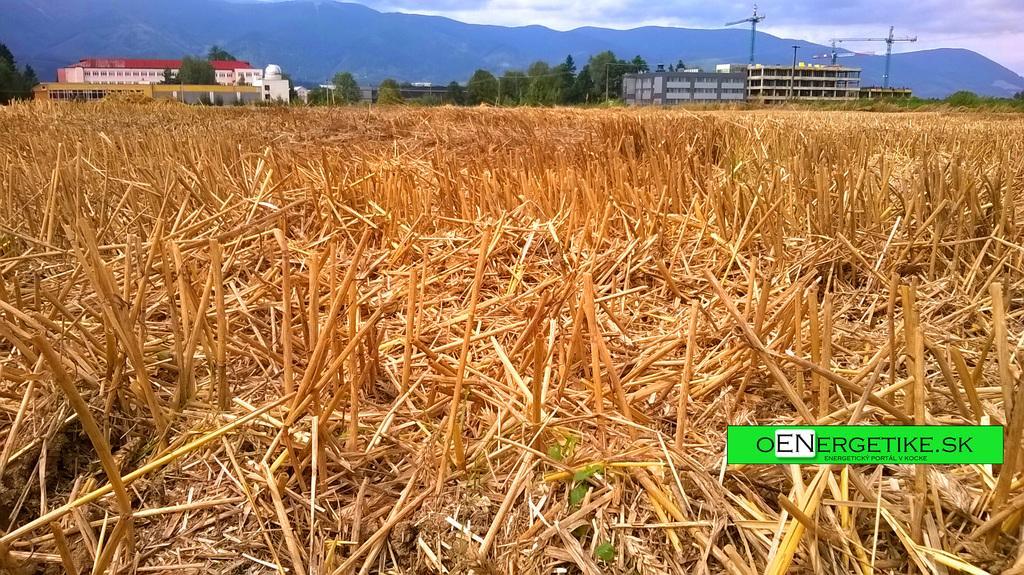Could you give a brief overview of what you see in this image? In this image at the bottom there are some plants, and in the background there are some buildings, trees, poles and mountains. 